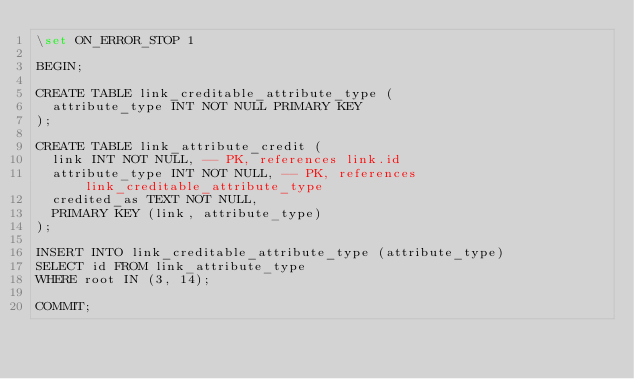Convert code to text. <code><loc_0><loc_0><loc_500><loc_500><_SQL_>\set ON_ERROR_STOP 1

BEGIN;

CREATE TABLE link_creditable_attribute_type (
  attribute_type INT NOT NULL PRIMARY KEY
);

CREATE TABLE link_attribute_credit (
  link INT NOT NULL, -- PK, references link.id
  attribute_type INT NOT NULL, -- PK, references link_creditable_attribute_type
  credited_as TEXT NOT NULL,
  PRIMARY KEY (link, attribute_type)
);

INSERT INTO link_creditable_attribute_type (attribute_type)
SELECT id FROM link_attribute_type
WHERE root IN (3, 14);

COMMIT;
</code> 